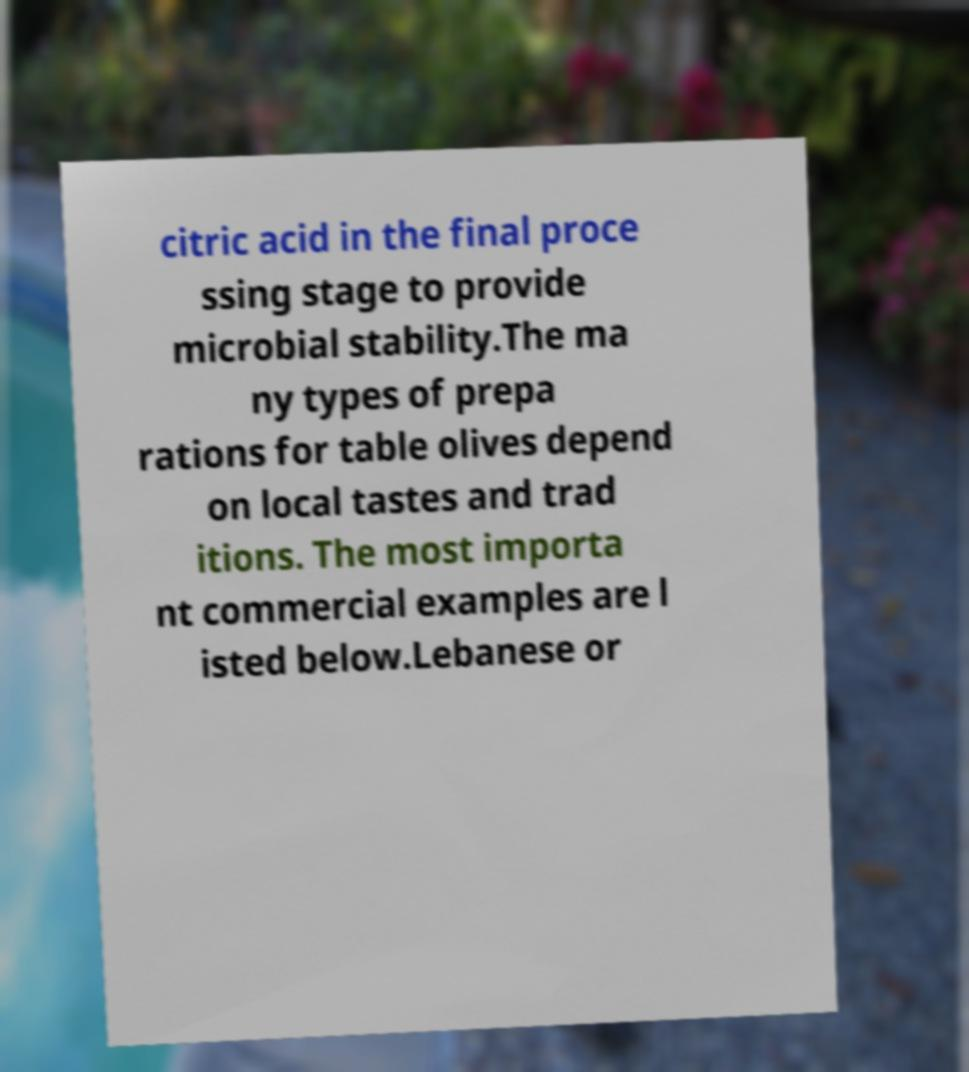Could you extract and type out the text from this image? citric acid in the final proce ssing stage to provide microbial stability.The ma ny types of prepa rations for table olives depend on local tastes and trad itions. The most importa nt commercial examples are l isted below.Lebanese or 